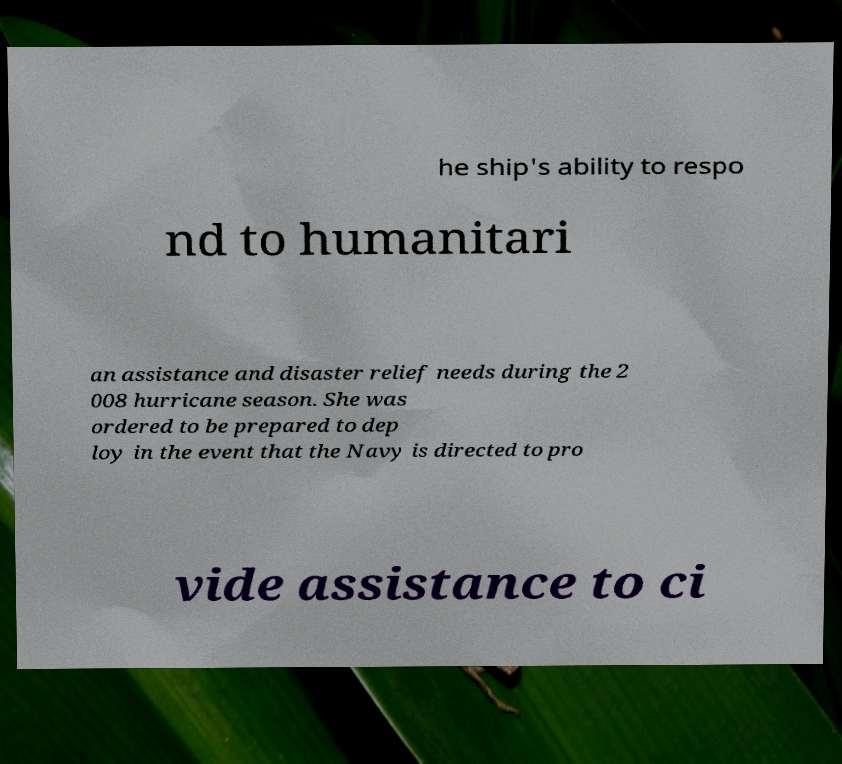Can you accurately transcribe the text from the provided image for me? he ship's ability to respo nd to humanitari an assistance and disaster relief needs during the 2 008 hurricane season. She was ordered to be prepared to dep loy in the event that the Navy is directed to pro vide assistance to ci 